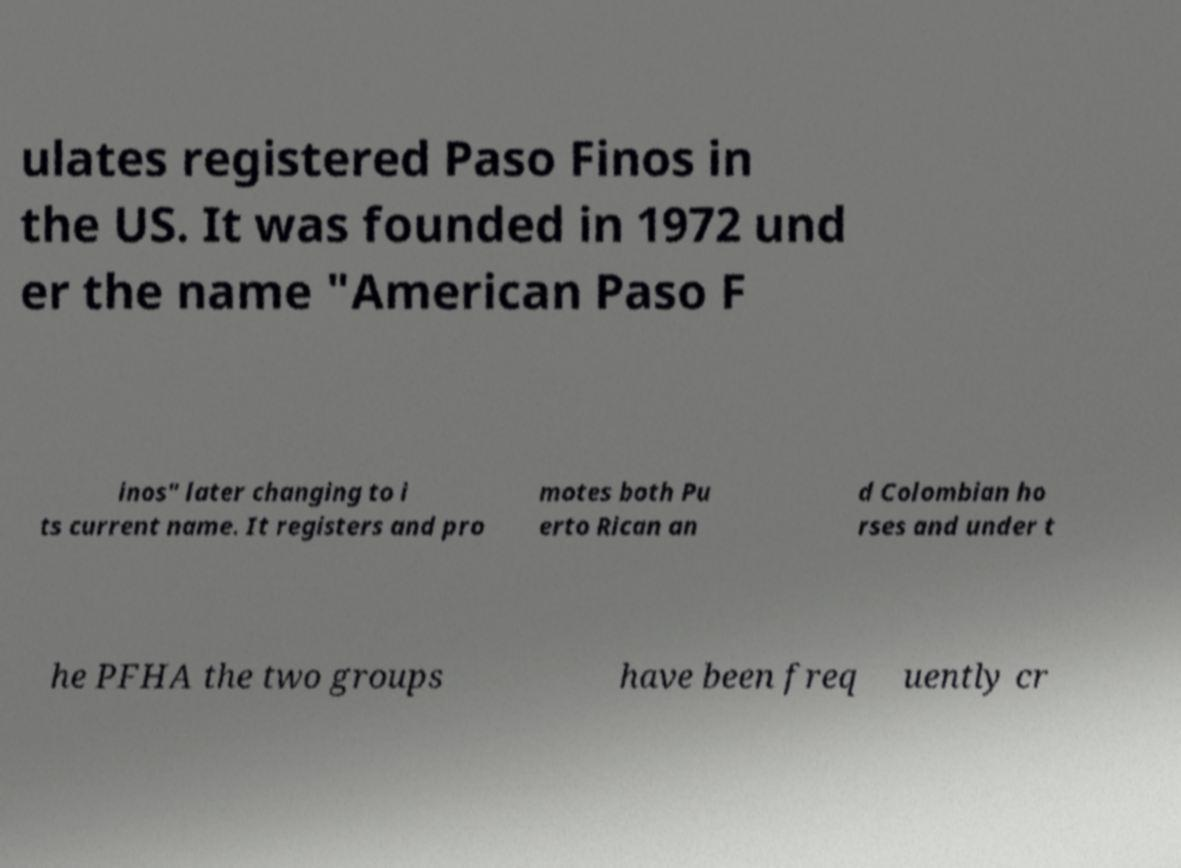Could you assist in decoding the text presented in this image and type it out clearly? ulates registered Paso Finos in the US. It was founded in 1972 und er the name "American Paso F inos" later changing to i ts current name. It registers and pro motes both Pu erto Rican an d Colombian ho rses and under t he PFHA the two groups have been freq uently cr 